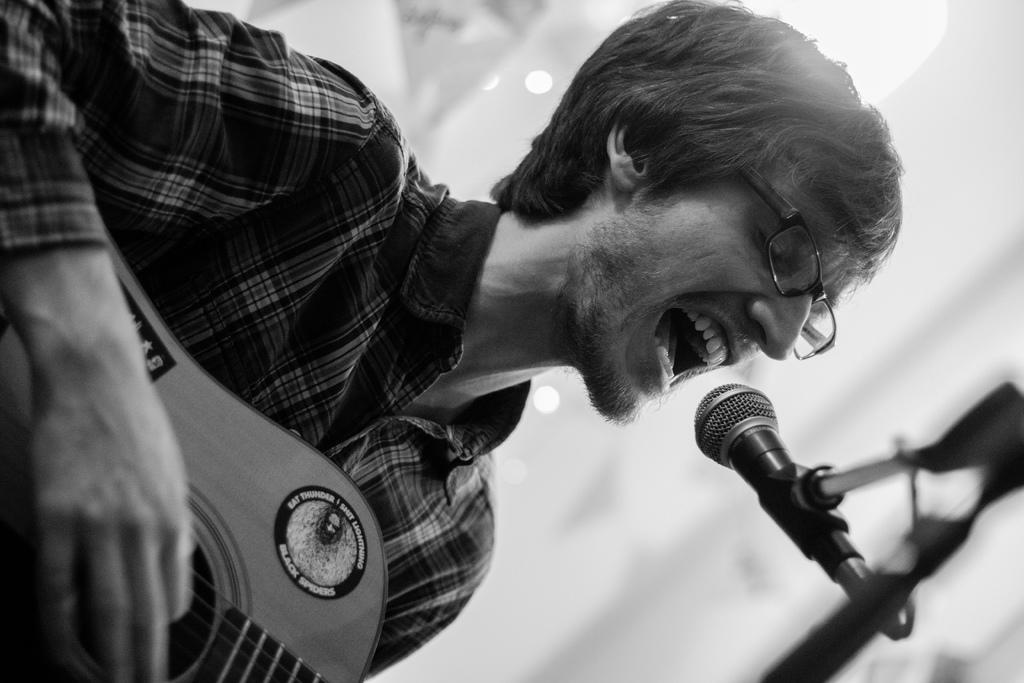What is the man in the image doing? The man is playing a guitar and singing. What object is the man using to amplify his voice? There is a microphone (mic) in the image. What type of coal is being used to create friction in the image? There is no coal or friction present in the image; it features a man playing a guitar and singing with a microphone. 